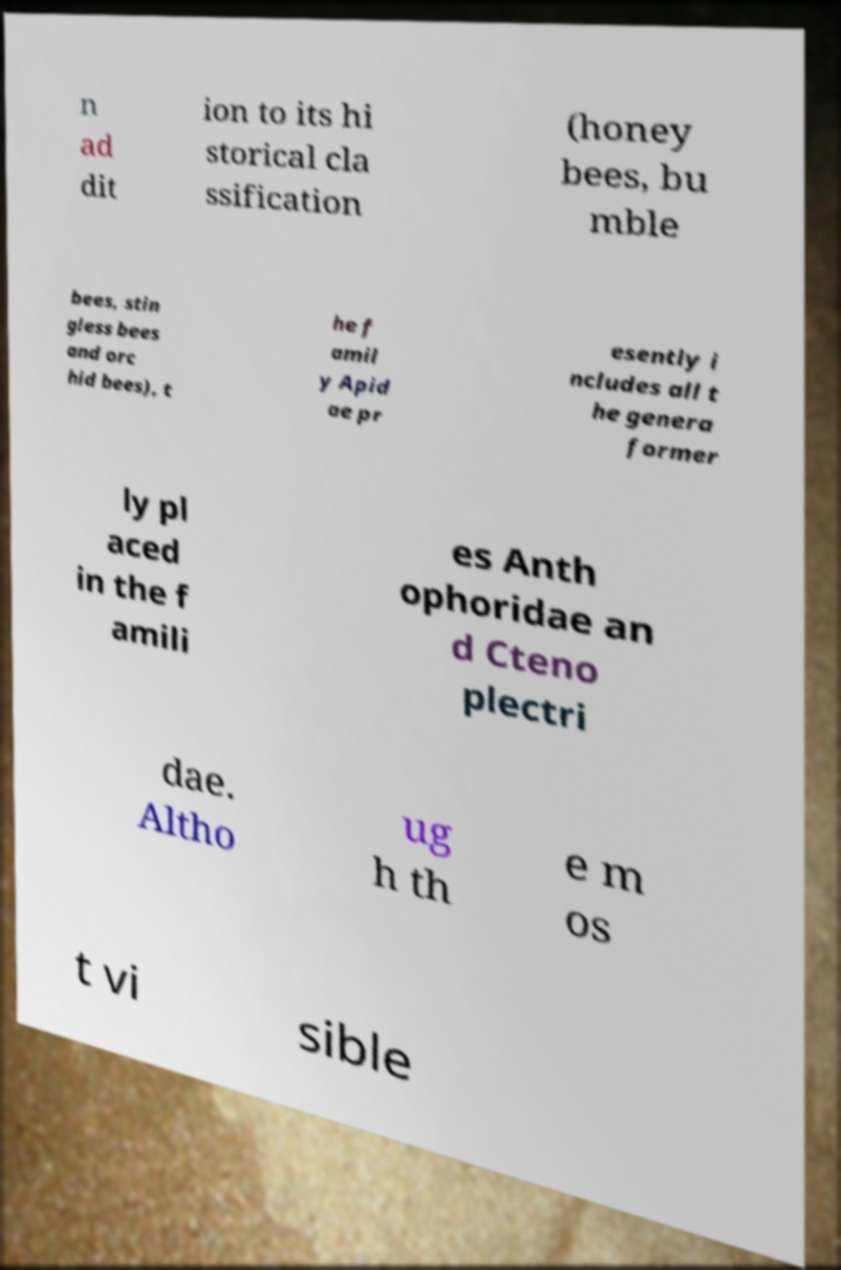Can you accurately transcribe the text from the provided image for me? n ad dit ion to its hi storical cla ssification (honey bees, bu mble bees, stin gless bees and orc hid bees), t he f amil y Apid ae pr esently i ncludes all t he genera former ly pl aced in the f amili es Anth ophoridae an d Cteno plectri dae. Altho ug h th e m os t vi sible 